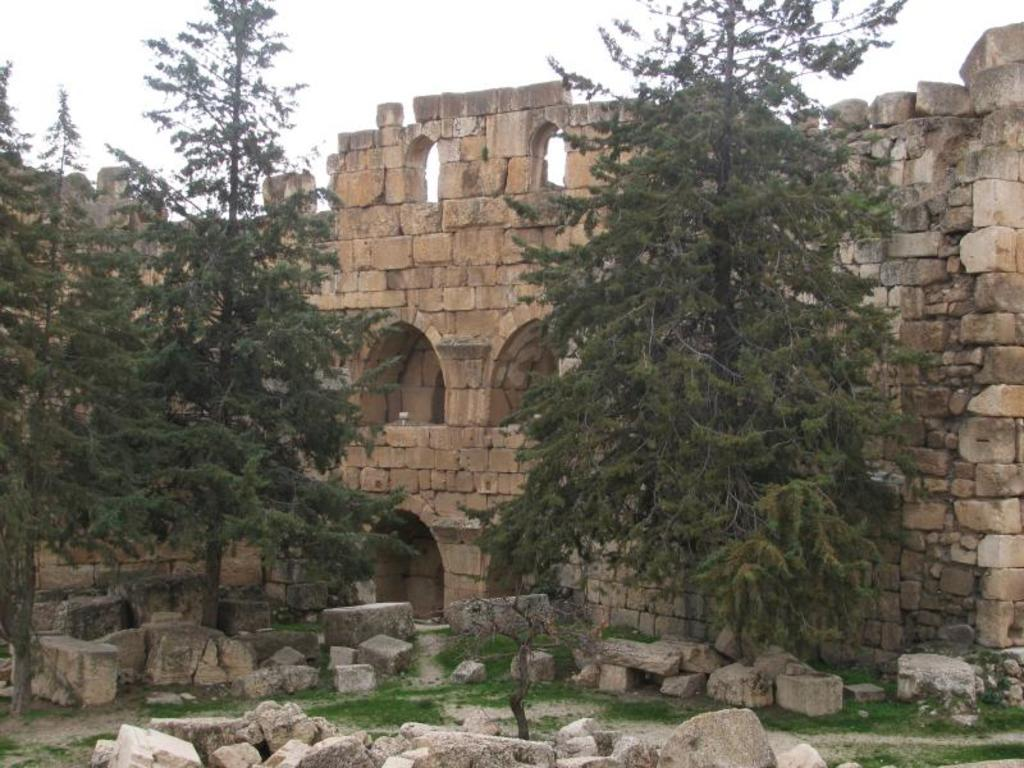What type of structure is visible in the image? There is a fort in the image. What can be seen in front of the fort? There are trees in front of the fort. What is happening around the fort? Cement blocks are falling around the fort. What type of ground cover is present between the cement blocks? There is grass between the cement blocks. Can you describe the texture of the eggnog in the image? There is no eggnog present in the image. How many toes are visible on the fort in the image? The fort is a structure and does not have toes. 